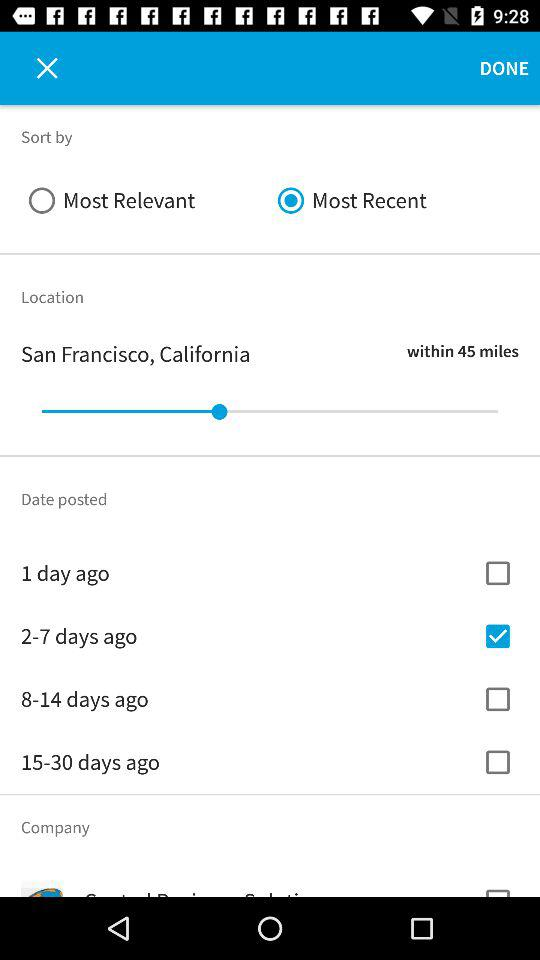How many checkboxes are there for filtering by date posted?
Answer the question using a single word or phrase. 4 